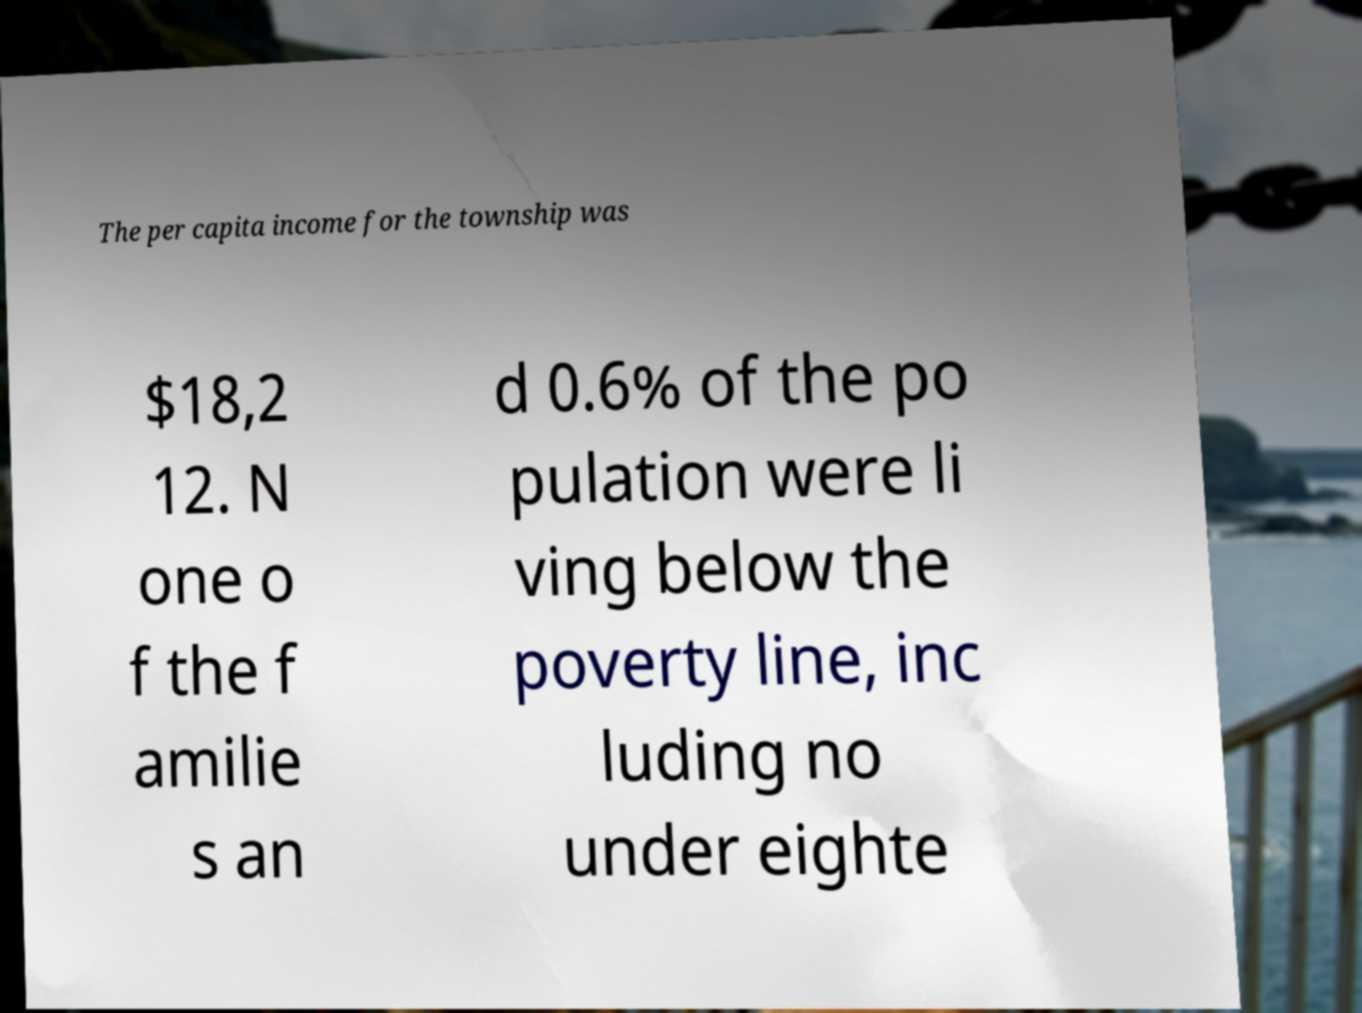Can you accurately transcribe the text from the provided image for me? The per capita income for the township was $18,2 12. N one o f the f amilie s an d 0.6% of the po pulation were li ving below the poverty line, inc luding no under eighte 